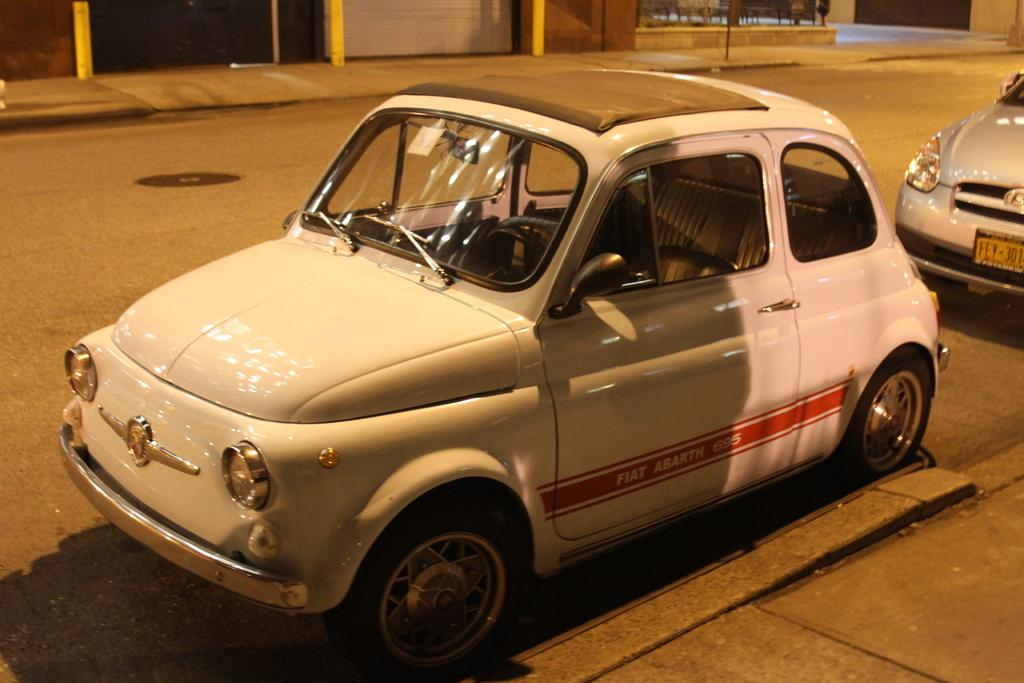What color is the car that is visible in the image? There is a white-colored car in the image. Where is the white-colored car located in the image? The white-colored car is on the road. Are there any other cars visible in the image? Yes, there is a silver-colored car in the image. How is the silver-colored car positioned in relation to the white-colored car? The silver-colored car is behind the white-colored car. What direction is the camera facing in the image? There is no camera present in the image, as it is a photograph taken by a camera. What is the motion of the white-colored car in the image? The motion of the white-colored car cannot be determined from the image alone, as it only shows a static snapshot of the scene. 